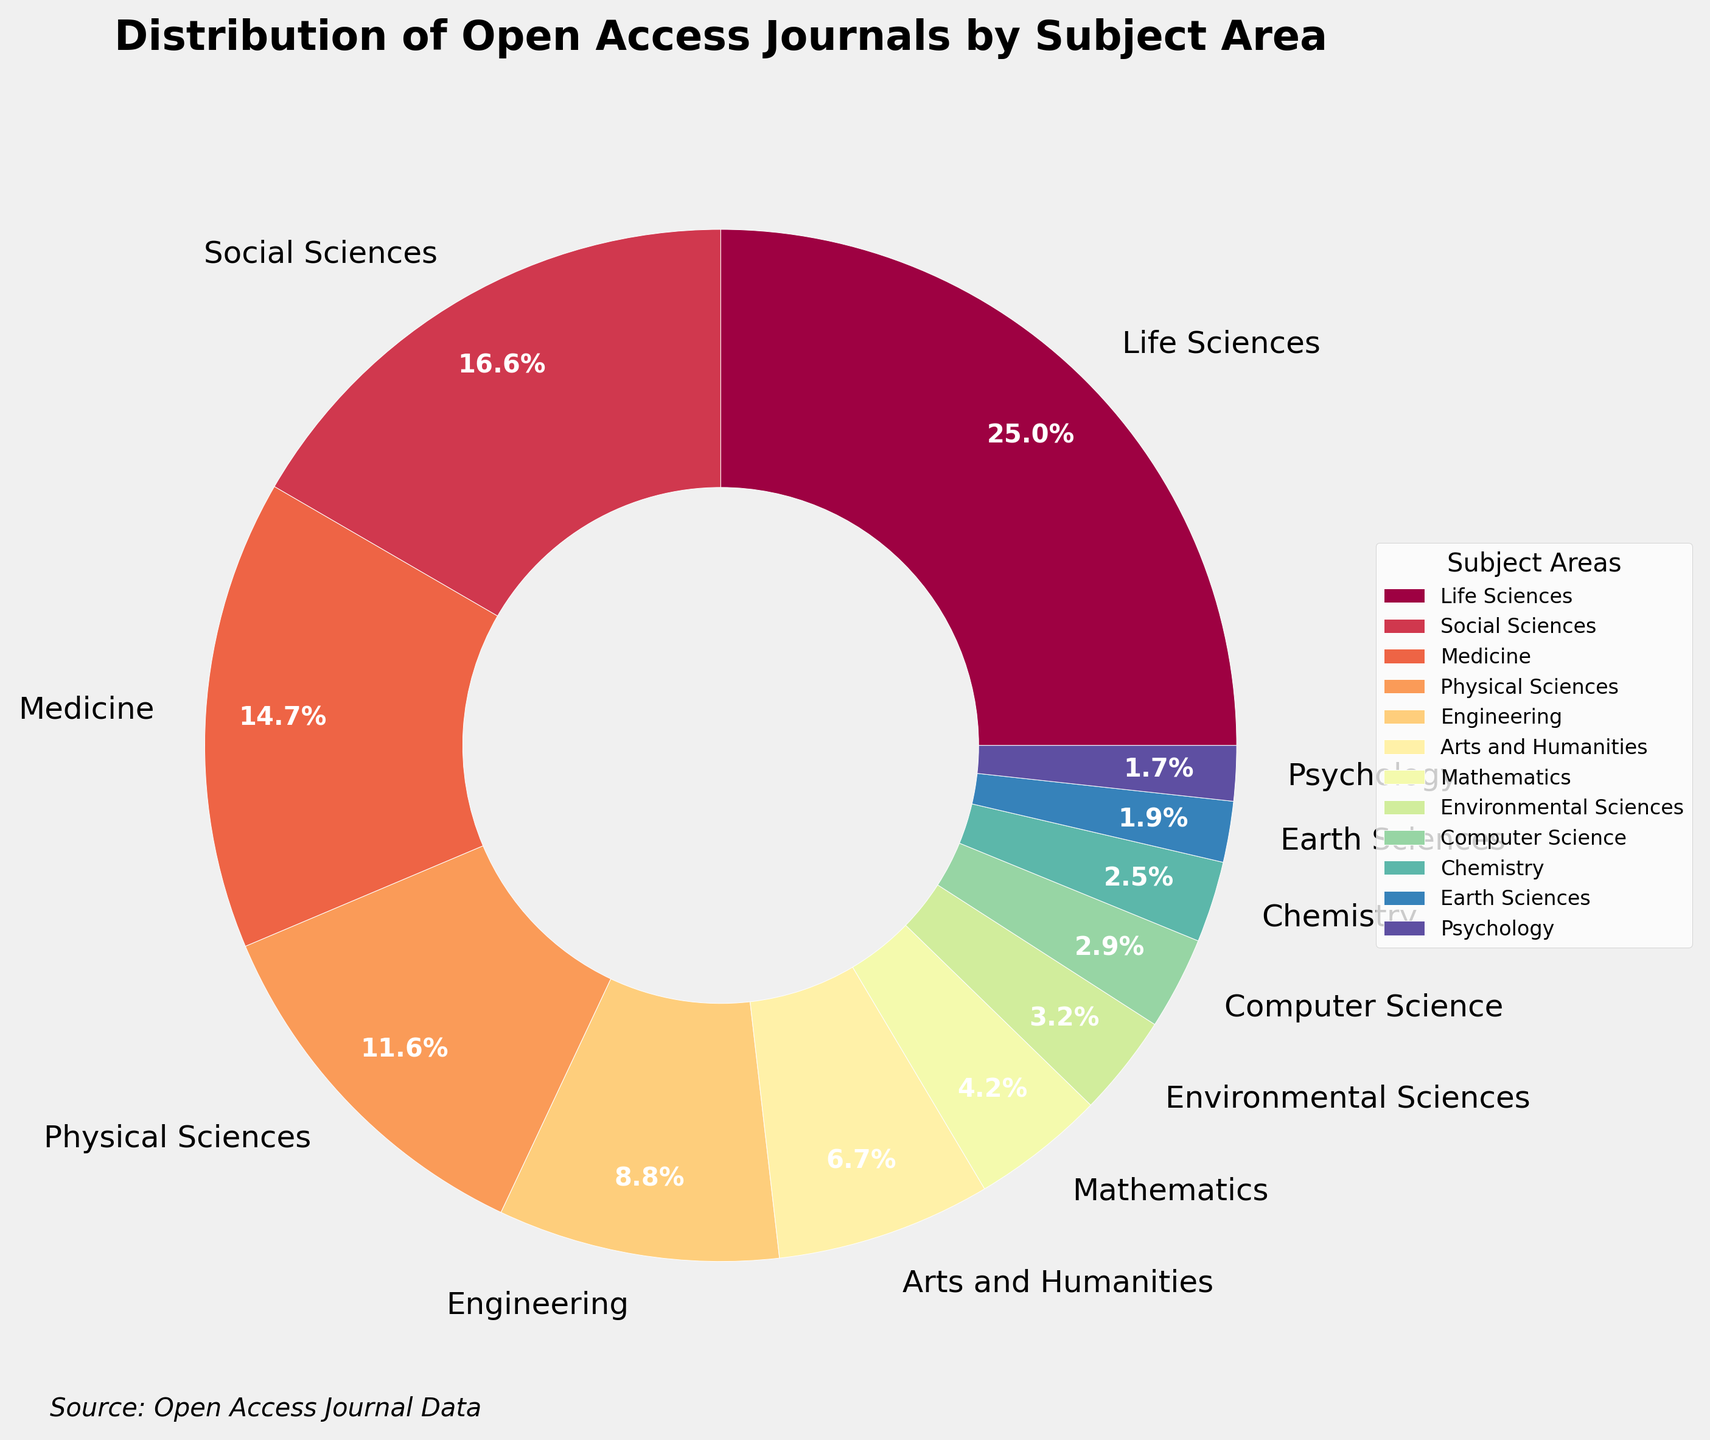Which subject area has the highest distribution of open access journals? By visual inspection of the pie chart, the segment that is largest represents the subject with the highest percentage. Life Sciences has the largest segment.
Answer: Life Sciences Which subject areas have a percentage distribution of open access journals greater than 10%? By looking at the labels of each segment in the pie chart, the segments for Life Sciences (27.5%), Social Sciences (18.3%), Medicine (16.2%), and Physical Sciences (12.8%) all have percentages greater than 10%.
Answer: Life Sciences, Social Sciences, Medicine, Physical Sciences What is the difference between the percentage distributions of Engineering and Computer Science? The percentage distribution for Engineering is 9.7% and for Computer Science, it is 3.2%. Subtracting these gives 9.7% - 3.2% = 6.5%.
Answer: 6.5% What is the combined percentage distribution of open access journals in Mathematics, Environmental Sciences, and Chemistry? The percentages for Mathematics, Environmental Sciences, and Chemistry are 4.6%, 3.5%, and 2.8% respectively. Adding these: 4.6% + 3.5% + 2.8% = 10.9%.
Answer: 10.9% Which subject area has the smallest distribution of open access journals and what is its percentage? The smallest segment in the pie chart is labeled Psychology, which has a percentage of 1.9%.
Answer: Psychology, 1.9% Compare the distribution percentages of Medicine and Arts and Humanities. Which one is higher and by how much? The percentage distribution of Medicine is 16.2% and Arts and Humanities is 7.4%. Medicine is higher. Subtracting these gives 16.2% - 7.4% = 8.8%.
Answer: Medicine by 8.8% Is the proportion of Engineering journals higher than that of Physical Sciences journals? By looking at the pie chart segments, Engineering has a percentage of 9.7% and Physical Sciences has a percentage of 12.8%. Since 9.7% is less than 12.8%, the proportion of Engineering journals is lower.
Answer: No What is the total percentage distribution of open access journals in the fields of Physical Sciences, Earth Sciences, and Mathematics? The percentages for Physical Sciences, Earth Sciences, and Mathematics are 12.8%, 2.1%, and 4.6% respectively. Adding these: 12.8% + 2.1% + 4.6% = 19.5%.
Answer: 19.5% How does the distribution of open access journals in Life Sciences compare to that in Medicine? The percentage distribution for Life Sciences is 27.5% and for Medicine, it is 16.2%. Since 27.5% is greater than 16.2%, Life Sciences has a higher distribution.
Answer: Life Sciences has a higher distribution 